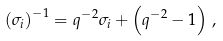Convert formula to latex. <formula><loc_0><loc_0><loc_500><loc_500>\left ( \sigma _ { i } \right ) ^ { - 1 } = q ^ { - 2 } \sigma _ { i } + \left ( q ^ { - 2 } - 1 \right ) \, ,</formula> 